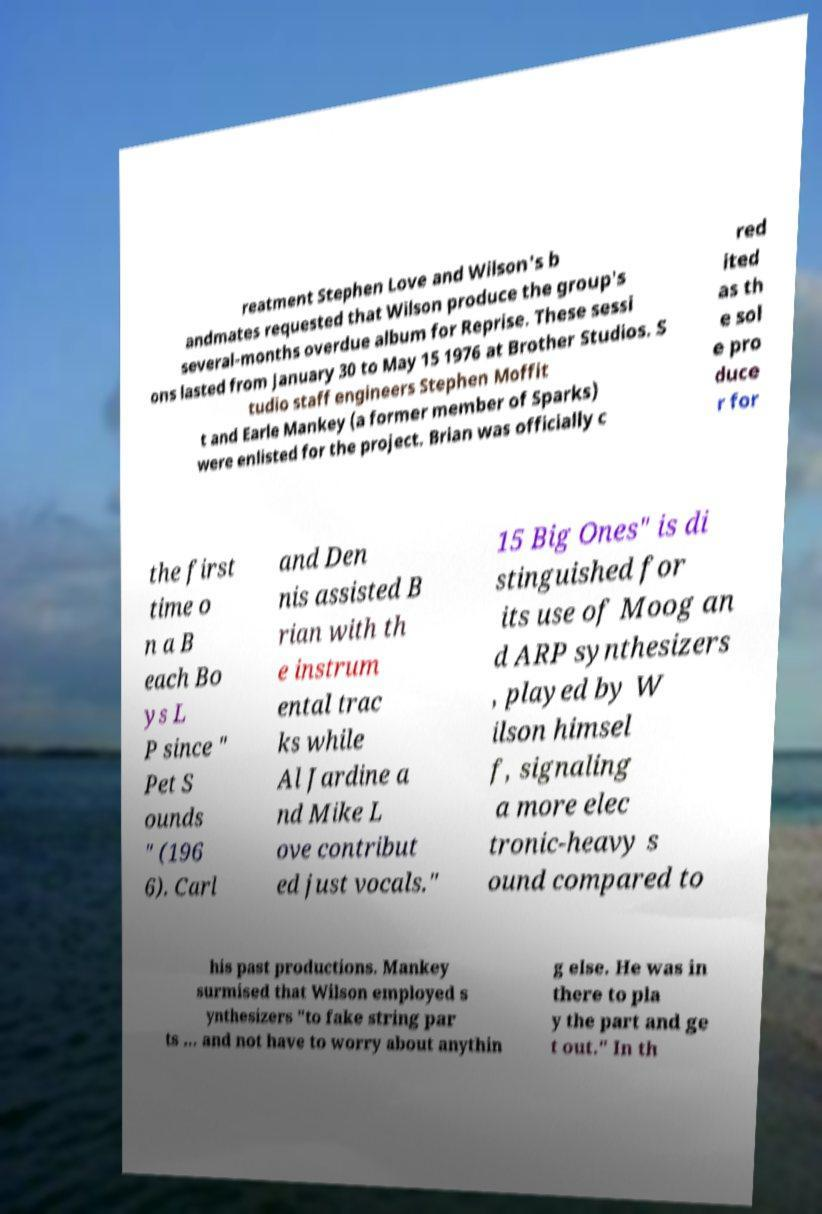For documentation purposes, I need the text within this image transcribed. Could you provide that? reatment Stephen Love and Wilson's b andmates requested that Wilson produce the group's several-months overdue album for Reprise. These sessi ons lasted from January 30 to May 15 1976 at Brother Studios. S tudio staff engineers Stephen Moffit t and Earle Mankey (a former member of Sparks) were enlisted for the project. Brian was officially c red ited as th e sol e pro duce r for the first time o n a B each Bo ys L P since " Pet S ounds " (196 6). Carl and Den nis assisted B rian with th e instrum ental trac ks while Al Jardine a nd Mike L ove contribut ed just vocals." 15 Big Ones" is di stinguished for its use of Moog an d ARP synthesizers , played by W ilson himsel f, signaling a more elec tronic-heavy s ound compared to his past productions. Mankey surmised that Wilson employed s ynthesizers "to fake string par ts ... and not have to worry about anythin g else. He was in there to pla y the part and ge t out." In th 